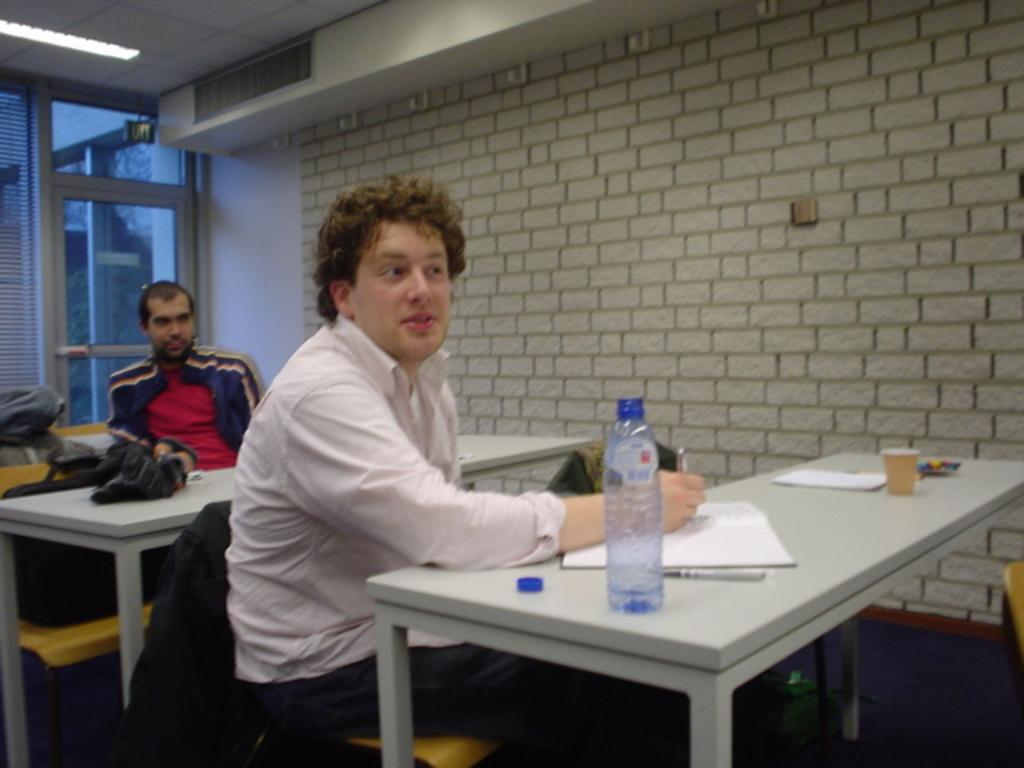How many people are sitting on the bench in the image? There are two persons sitting on a bench in the image. What objects can be seen on the table in the image? There is a bottle, a book, and a cup on the table in the image. What is visible in the background of the image? There is a wall and a glass in the background of the image. What type of servant can be seen attending to the persons in the image? There is no servant present in the image; it only shows two persons sitting on a bench and objects on a table. What color is the sky in the image? The provided facts do not mention the sky, so we cannot determine its color from the image. 